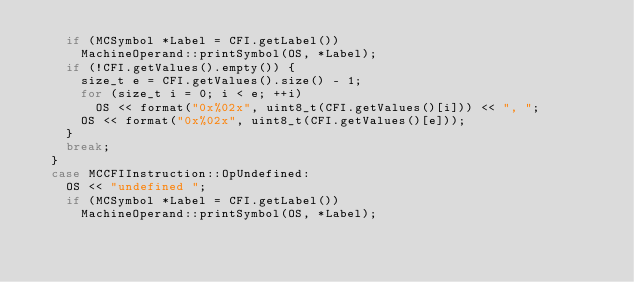Convert code to text. <code><loc_0><loc_0><loc_500><loc_500><_C++_>    if (MCSymbol *Label = CFI.getLabel())
      MachineOperand::printSymbol(OS, *Label);
    if (!CFI.getValues().empty()) {
      size_t e = CFI.getValues().size() - 1;
      for (size_t i = 0; i < e; ++i)
        OS << format("0x%02x", uint8_t(CFI.getValues()[i])) << ", ";
      OS << format("0x%02x", uint8_t(CFI.getValues()[e]));
    }
    break;
  }
  case MCCFIInstruction::OpUndefined:
    OS << "undefined ";
    if (MCSymbol *Label = CFI.getLabel())
      MachineOperand::printSymbol(OS, *Label);</code> 